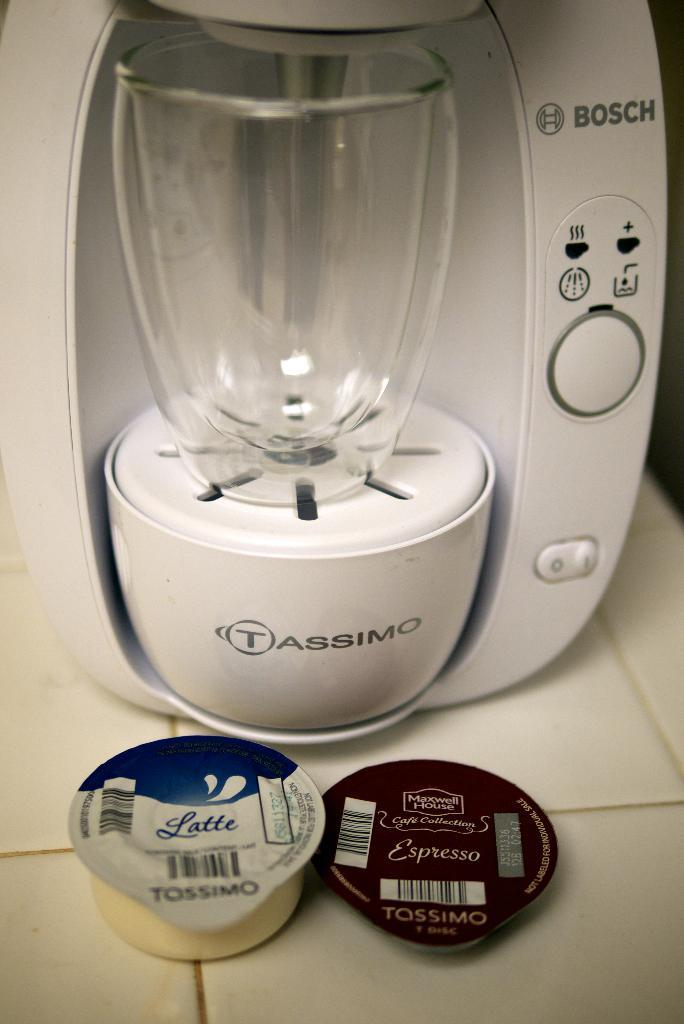<image>
Provide a brief description of the given image. In front of the coffee maker are a latte pod and an espresso pod. 